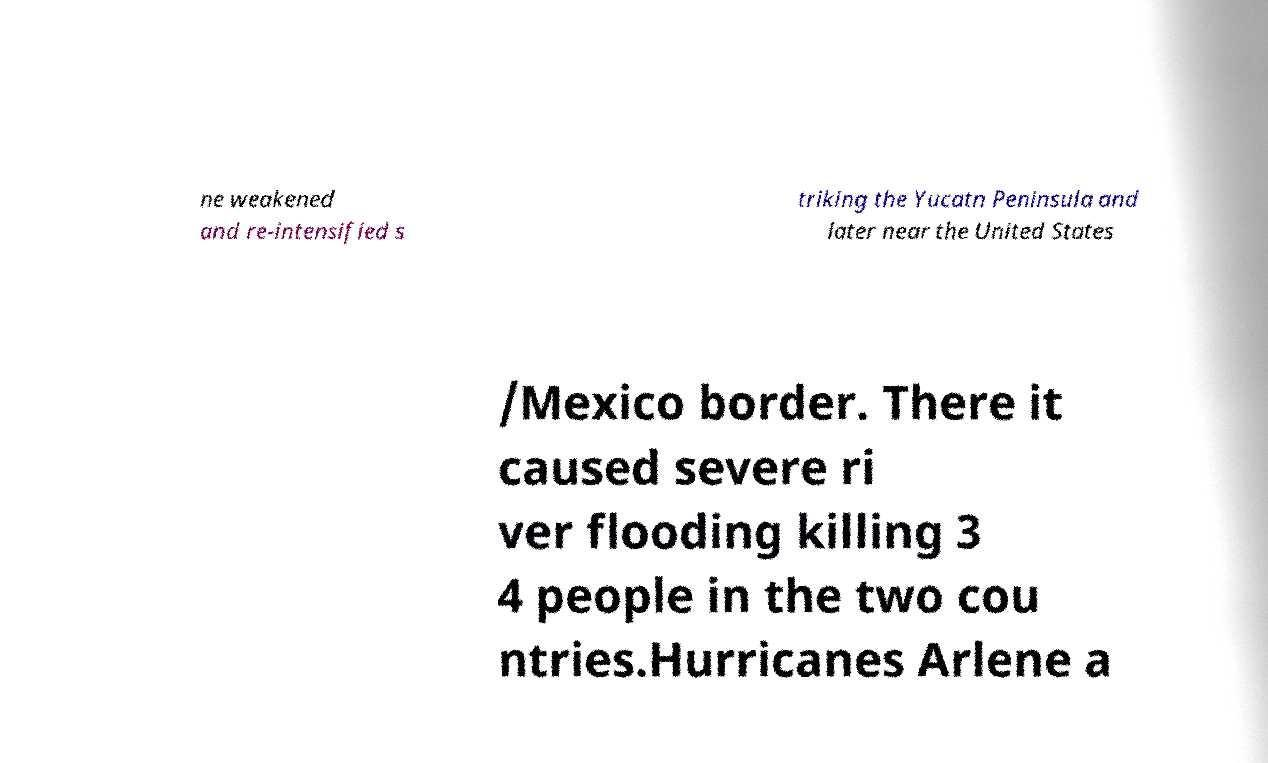Please identify and transcribe the text found in this image. ne weakened and re-intensified s triking the Yucatn Peninsula and later near the United States /Mexico border. There it caused severe ri ver flooding killing 3 4 people in the two cou ntries.Hurricanes Arlene a 